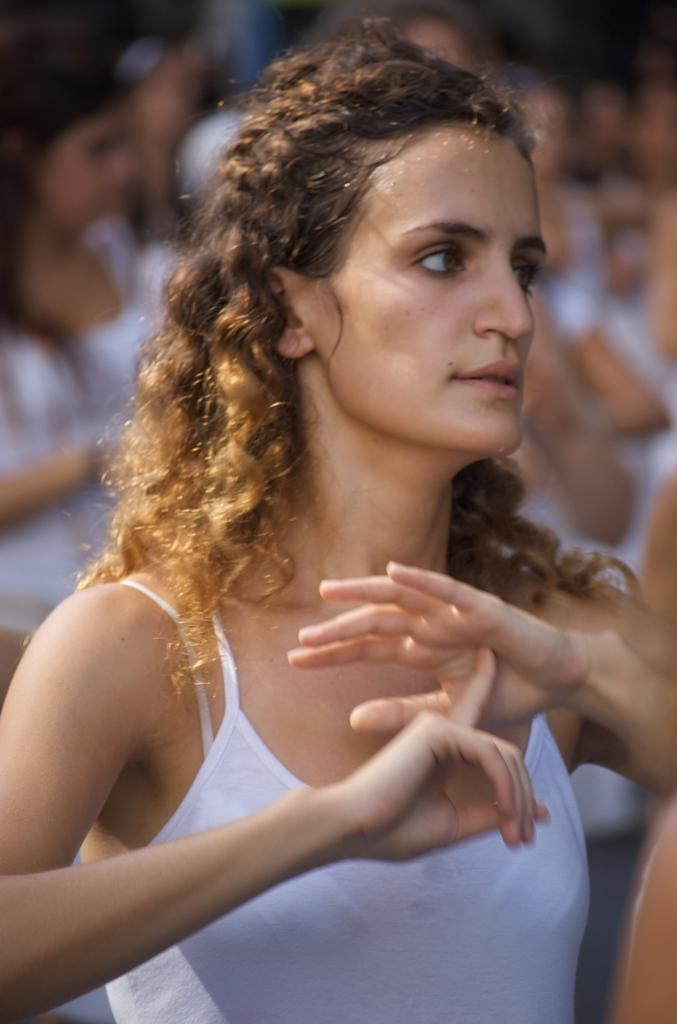What is the main subject of the image? The main subject of the image is a woman. What is the woman doing in the image? The woman is standing in the image. What is the woman wearing in the image? The woman is wearing a white vest in the image. Can you describe the background of the image? The background of the image is blurred. What type of cracker is the woman holding in the image? There is no cracker present in the image. What kind of stone is visible in the background of the image? There is no stone visible in the background of the image. What color is the cream that the woman is applying to her face in the image? There is no cream or any activity related to applying cream in the image. 